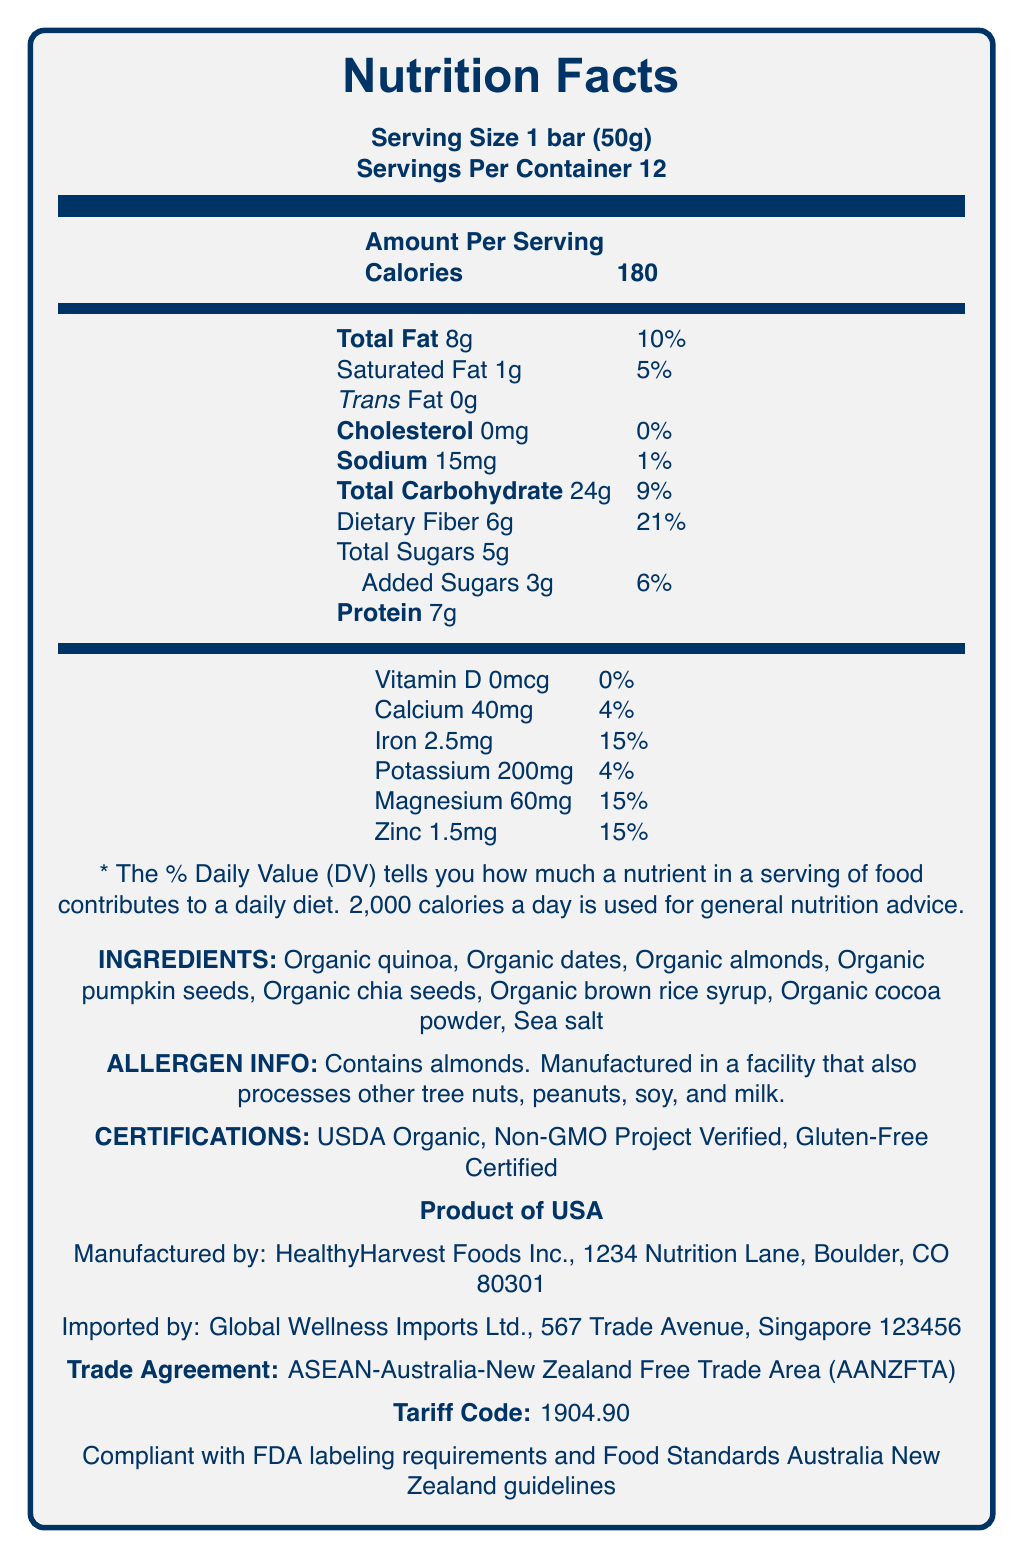what is the serving size of the QuinoaPower Superfood Bar? The serving size is directly stated as "Serving Size 1 bar (50g)" in the document.
Answer: 1 bar (50g) How many calories are there per serving of the QuinoaPower Superfood Bar? The calories per serving are listed as "Calories 180" in the document.
Answer: 180 what is the amount of dietary fiber per serving? The amount of dietary fiber per serving is listed as "Dietary Fiber 6g".
Answer: 6g What percentage of the daily value for iron does the QuinoaPower Superfood Bar provide per serving? The document states "Iron 2.5mg" which corresponds to 15% of the daily value.
Answer: 15% What are the main ingredients of the QuinoaPower Superfood Bar? These ingredients are listed under the "INGREDIENTS" section.
Answer: Organic quinoa, Organic dates, Organic almonds, Organic pumpkin seeds, Organic chia seeds, Organic brown rice syrup, Organic cocoa powder, Sea salt What is the country of origin for the QuinoaPower Superfood Bar? A. Canada B. USA C. Australia D. New Zealand The document specifies "Product of USA" under the country of origin section.
Answer: B. USA Which certification does NOT appear on the QuinoaPower Superfood Bar label? A. USDA Organic B. Non-GMO Project Verified C. Gluten-Free Certified D. Fair Trade Certified "Fair Trade Certified" is not listed among the certifications on the document.
Answer: D. Fair Trade Certified Does the QuinoaPower Superfood Bar contain any added sugars? The document lists "Added Sugars 3g" under the nutritional information.
Answer: Yes Is the QuinoaPower Superfood Bar compliant with FDA labeling requirements? The document explicitly states "Compliant with FDA labeling requirements".
Answer: Yes Summarize the entire document. The document provides comprehensive information about the nutritional content, ingredient details, certifications, and regulatory compliance of the QuinoaPower Superfood Bar, ensuring transparency and adherence to food standards.
Answer: The document details the Nutrition Facts label for the QuinoaPower Superfood Bar, including serving size, calories, and specific nutrient content such as dietary fiber and minerals. It lists ingredients, allergen information, certifications, country of origin, manufacturer and importer details, trade agreement, tariff code, and regulatory compliance. What is the expiration date of the QuinoaPower Superfood Bar? The expiration date is not mentioned anywhere within the provided document.
Answer: Cannot be determined 